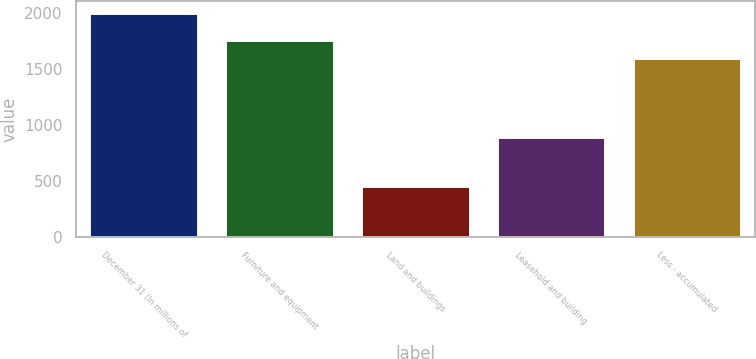<chart> <loc_0><loc_0><loc_500><loc_500><bar_chart><fcel>December 31 (In millions of<fcel>Furniture and equipment<fcel>Land and buildings<fcel>Leasehold and building<fcel>Less - accumulated<nl><fcel>2004<fcel>1757.7<fcel>457<fcel>897<fcel>1603<nl></chart> 